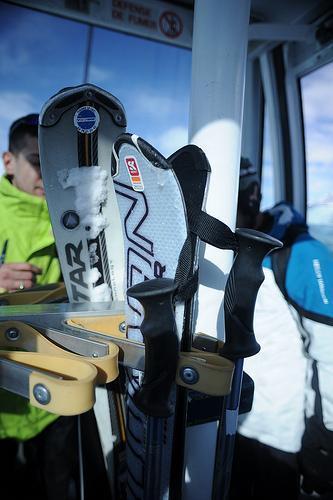How many men are there?
Give a very brief answer. 1. 